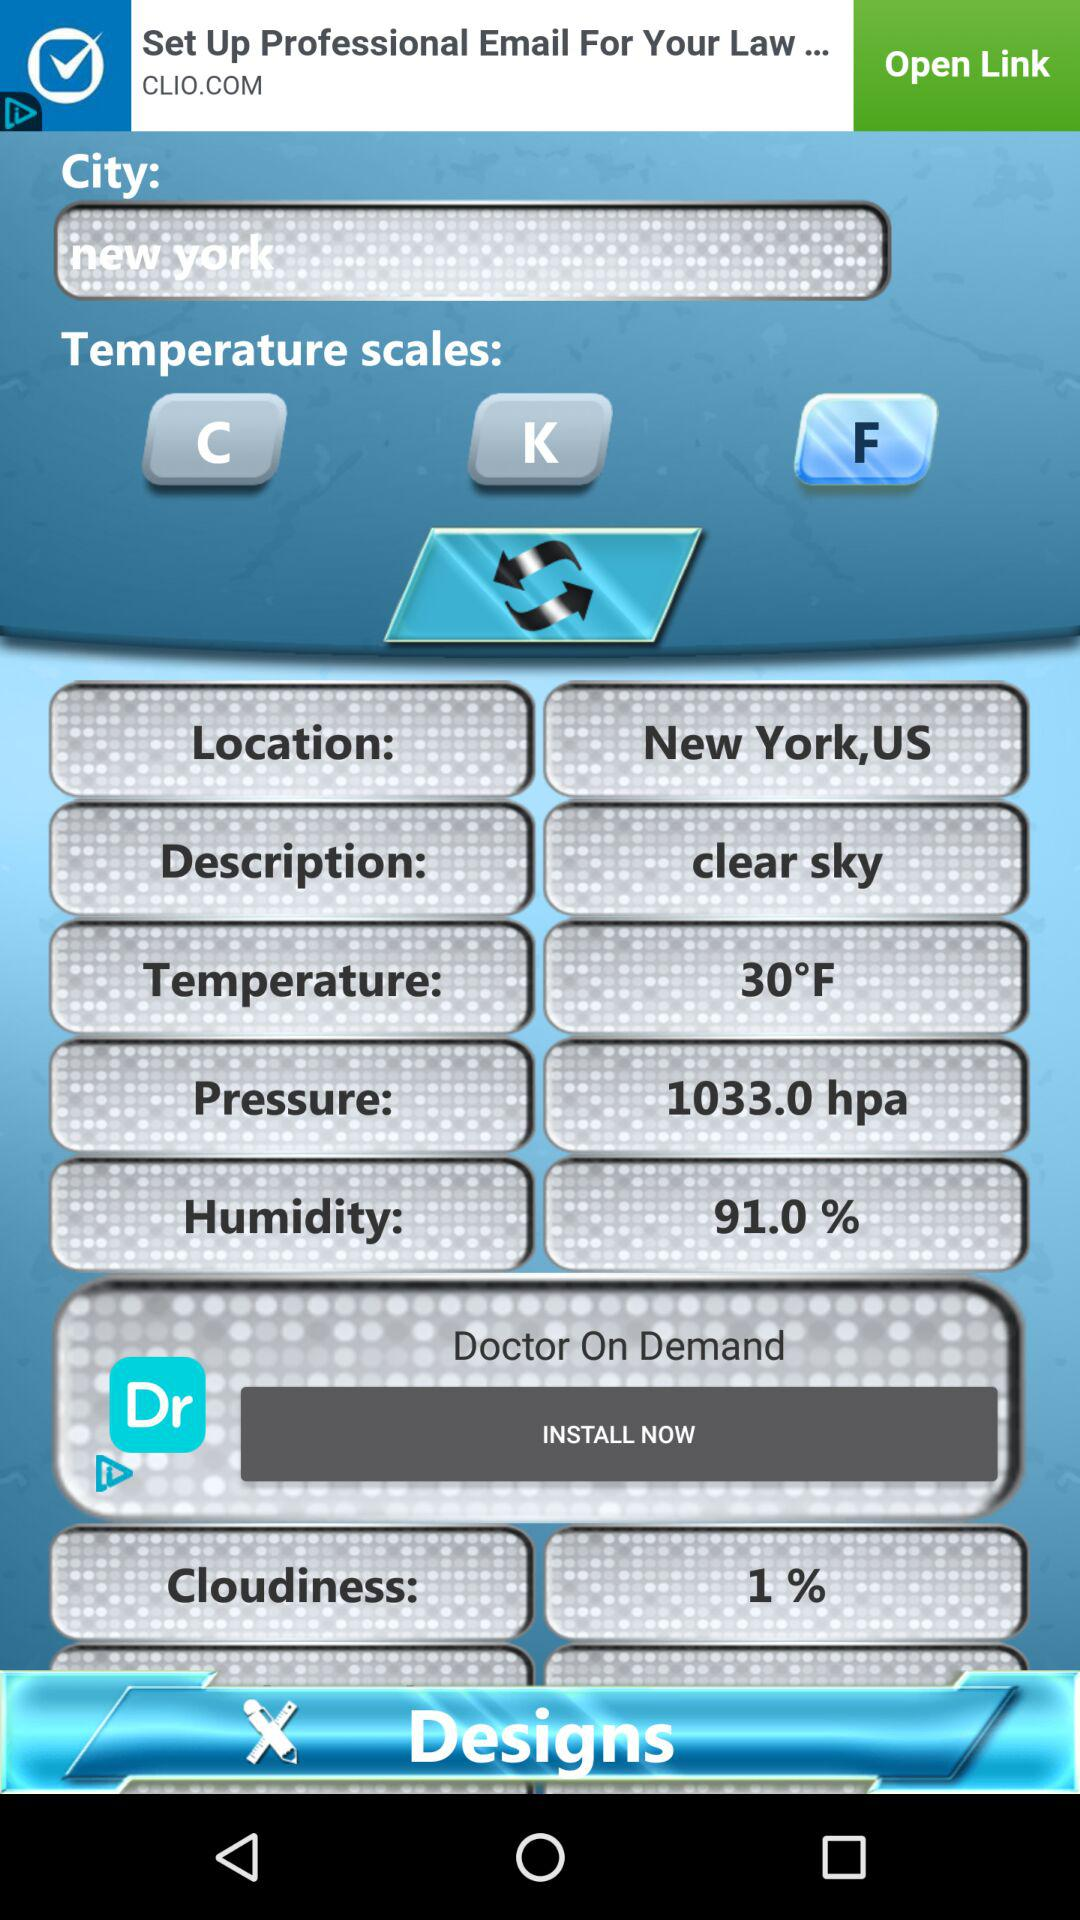What is the mentioned location? The mentioned location is New York, US. 